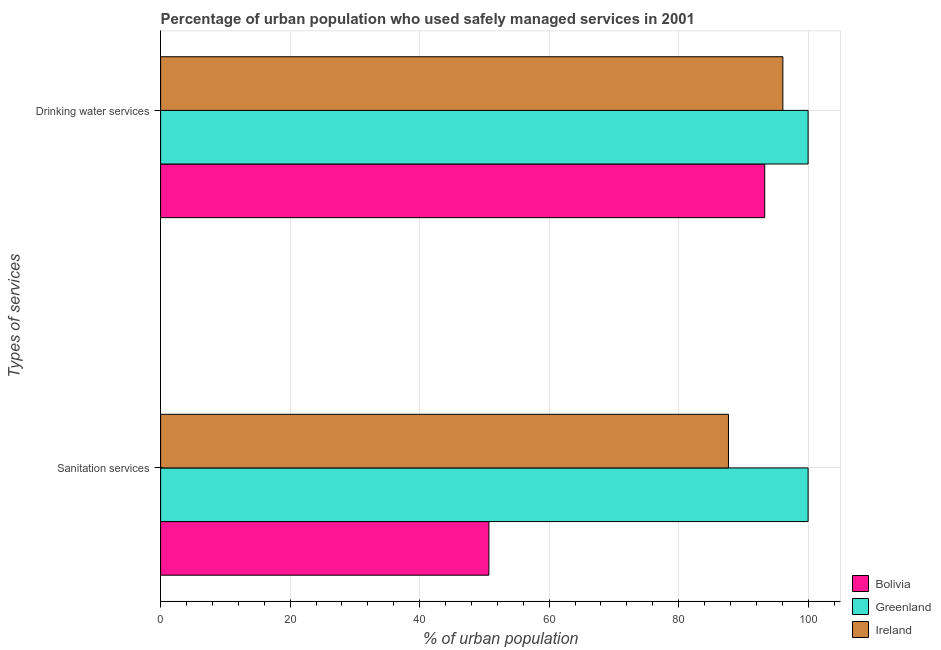How many different coloured bars are there?
Offer a very short reply. 3. How many groups of bars are there?
Provide a short and direct response. 2. Are the number of bars per tick equal to the number of legend labels?
Your answer should be very brief. Yes. How many bars are there on the 2nd tick from the top?
Keep it short and to the point. 3. What is the label of the 2nd group of bars from the top?
Give a very brief answer. Sanitation services. What is the percentage of urban population who used drinking water services in Ireland?
Offer a very short reply. 96.1. Across all countries, what is the maximum percentage of urban population who used drinking water services?
Offer a very short reply. 100. Across all countries, what is the minimum percentage of urban population who used drinking water services?
Your answer should be very brief. 93.3. In which country was the percentage of urban population who used drinking water services maximum?
Provide a succinct answer. Greenland. In which country was the percentage of urban population who used sanitation services minimum?
Provide a succinct answer. Bolivia. What is the total percentage of urban population who used drinking water services in the graph?
Make the answer very short. 289.4. What is the difference between the percentage of urban population who used sanitation services in Bolivia and that in Greenland?
Offer a terse response. -49.3. What is the difference between the percentage of urban population who used drinking water services in Greenland and the percentage of urban population who used sanitation services in Bolivia?
Your response must be concise. 49.3. What is the average percentage of urban population who used drinking water services per country?
Give a very brief answer. 96.47. What is the difference between the percentage of urban population who used drinking water services and percentage of urban population who used sanitation services in Ireland?
Your answer should be very brief. 8.4. In how many countries, is the percentage of urban population who used sanitation services greater than 4 %?
Make the answer very short. 3. What is the ratio of the percentage of urban population who used sanitation services in Bolivia to that in Greenland?
Ensure brevity in your answer.  0.51. What does the 3rd bar from the top in Sanitation services represents?
Your response must be concise. Bolivia. What does the 1st bar from the bottom in Sanitation services represents?
Provide a short and direct response. Bolivia. Does the graph contain grids?
Your response must be concise. Yes. Where does the legend appear in the graph?
Your response must be concise. Bottom right. What is the title of the graph?
Provide a succinct answer. Percentage of urban population who used safely managed services in 2001. What is the label or title of the X-axis?
Provide a short and direct response. % of urban population. What is the label or title of the Y-axis?
Your answer should be very brief. Types of services. What is the % of urban population in Bolivia in Sanitation services?
Your answer should be very brief. 50.7. What is the % of urban population in Ireland in Sanitation services?
Keep it short and to the point. 87.7. What is the % of urban population of Bolivia in Drinking water services?
Offer a very short reply. 93.3. What is the % of urban population in Greenland in Drinking water services?
Provide a short and direct response. 100. What is the % of urban population of Ireland in Drinking water services?
Offer a terse response. 96.1. Across all Types of services, what is the maximum % of urban population of Bolivia?
Ensure brevity in your answer.  93.3. Across all Types of services, what is the maximum % of urban population in Ireland?
Offer a very short reply. 96.1. Across all Types of services, what is the minimum % of urban population in Bolivia?
Offer a terse response. 50.7. Across all Types of services, what is the minimum % of urban population of Greenland?
Make the answer very short. 100. Across all Types of services, what is the minimum % of urban population of Ireland?
Make the answer very short. 87.7. What is the total % of urban population of Bolivia in the graph?
Give a very brief answer. 144. What is the total % of urban population of Greenland in the graph?
Offer a very short reply. 200. What is the total % of urban population of Ireland in the graph?
Your answer should be compact. 183.8. What is the difference between the % of urban population of Bolivia in Sanitation services and that in Drinking water services?
Keep it short and to the point. -42.6. What is the difference between the % of urban population in Ireland in Sanitation services and that in Drinking water services?
Keep it short and to the point. -8.4. What is the difference between the % of urban population in Bolivia in Sanitation services and the % of urban population in Greenland in Drinking water services?
Give a very brief answer. -49.3. What is the difference between the % of urban population of Bolivia in Sanitation services and the % of urban population of Ireland in Drinking water services?
Your response must be concise. -45.4. What is the difference between the % of urban population in Greenland in Sanitation services and the % of urban population in Ireland in Drinking water services?
Offer a very short reply. 3.9. What is the average % of urban population of Bolivia per Types of services?
Offer a terse response. 72. What is the average % of urban population in Ireland per Types of services?
Your response must be concise. 91.9. What is the difference between the % of urban population in Bolivia and % of urban population in Greenland in Sanitation services?
Give a very brief answer. -49.3. What is the difference between the % of urban population of Bolivia and % of urban population of Ireland in Sanitation services?
Provide a short and direct response. -37. What is the difference between the % of urban population in Greenland and % of urban population in Ireland in Sanitation services?
Provide a short and direct response. 12.3. What is the difference between the % of urban population of Bolivia and % of urban population of Greenland in Drinking water services?
Ensure brevity in your answer.  -6.7. What is the difference between the % of urban population in Bolivia and % of urban population in Ireland in Drinking water services?
Provide a short and direct response. -2.8. What is the difference between the % of urban population of Greenland and % of urban population of Ireland in Drinking water services?
Provide a succinct answer. 3.9. What is the ratio of the % of urban population in Bolivia in Sanitation services to that in Drinking water services?
Give a very brief answer. 0.54. What is the ratio of the % of urban population in Ireland in Sanitation services to that in Drinking water services?
Keep it short and to the point. 0.91. What is the difference between the highest and the second highest % of urban population in Bolivia?
Offer a very short reply. 42.6. What is the difference between the highest and the second highest % of urban population of Greenland?
Make the answer very short. 0. What is the difference between the highest and the second highest % of urban population in Ireland?
Your answer should be compact. 8.4. What is the difference between the highest and the lowest % of urban population of Bolivia?
Offer a terse response. 42.6. What is the difference between the highest and the lowest % of urban population in Greenland?
Offer a terse response. 0. 